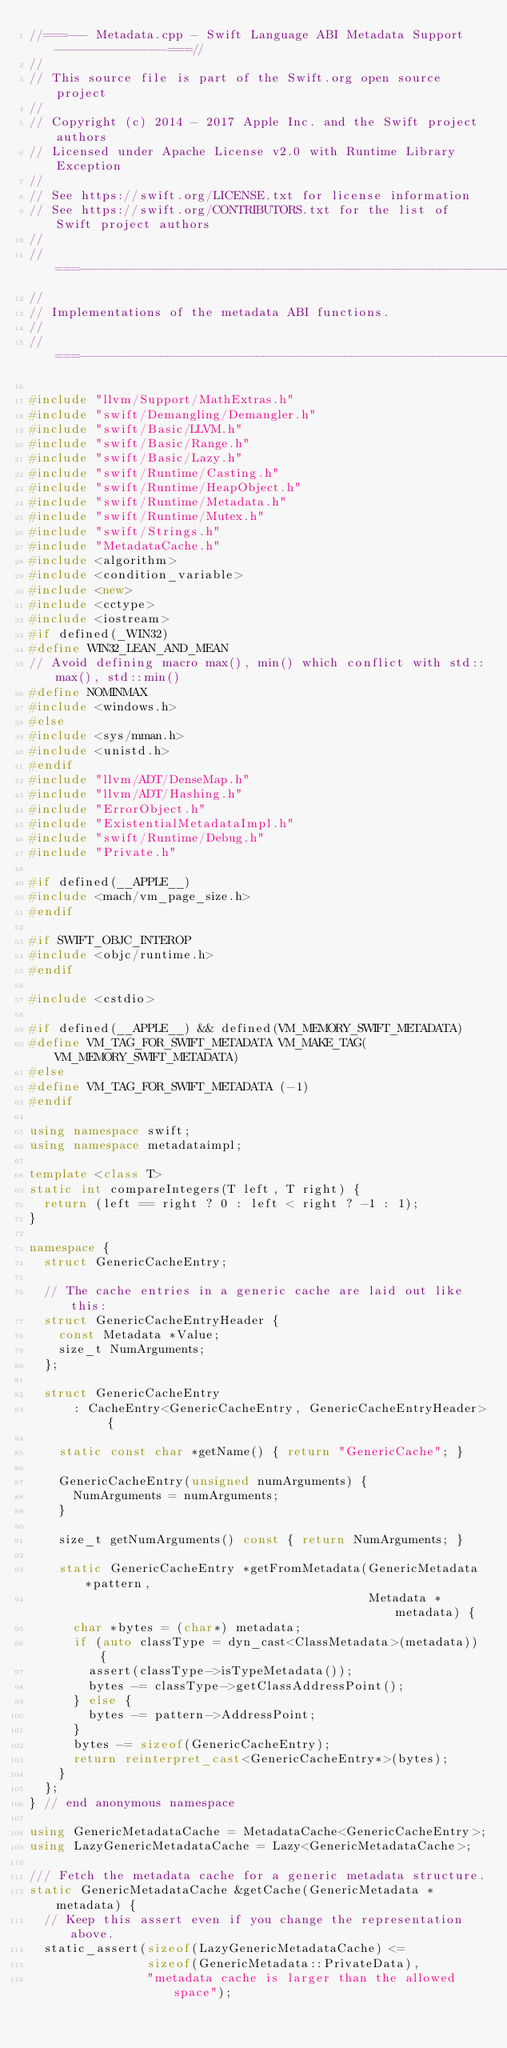<code> <loc_0><loc_0><loc_500><loc_500><_C++_>//===--- Metadata.cpp - Swift Language ABI Metadata Support ---------------===//
//
// This source file is part of the Swift.org open source project
//
// Copyright (c) 2014 - 2017 Apple Inc. and the Swift project authors
// Licensed under Apache License v2.0 with Runtime Library Exception
//
// See https://swift.org/LICENSE.txt for license information
// See https://swift.org/CONTRIBUTORS.txt for the list of Swift project authors
//
//===----------------------------------------------------------------------===//
//
// Implementations of the metadata ABI functions.
//
//===----------------------------------------------------------------------===//

#include "llvm/Support/MathExtras.h"
#include "swift/Demangling/Demangler.h"
#include "swift/Basic/LLVM.h"
#include "swift/Basic/Range.h"
#include "swift/Basic/Lazy.h"
#include "swift/Runtime/Casting.h"
#include "swift/Runtime/HeapObject.h"
#include "swift/Runtime/Metadata.h"
#include "swift/Runtime/Mutex.h"
#include "swift/Strings.h"
#include "MetadataCache.h"
#include <algorithm>
#include <condition_variable>
#include <new>
#include <cctype>
#include <iostream>
#if defined(_WIN32)
#define WIN32_LEAN_AND_MEAN
// Avoid defining macro max(), min() which conflict with std::max(), std::min()
#define NOMINMAX
#include <windows.h>
#else
#include <sys/mman.h>
#include <unistd.h>
#endif
#include "llvm/ADT/DenseMap.h"
#include "llvm/ADT/Hashing.h"
#include "ErrorObject.h"
#include "ExistentialMetadataImpl.h"
#include "swift/Runtime/Debug.h"
#include "Private.h"

#if defined(__APPLE__)
#include <mach/vm_page_size.h>
#endif

#if SWIFT_OBJC_INTEROP
#include <objc/runtime.h>
#endif

#include <cstdio>

#if defined(__APPLE__) && defined(VM_MEMORY_SWIFT_METADATA)
#define VM_TAG_FOR_SWIFT_METADATA VM_MAKE_TAG(VM_MEMORY_SWIFT_METADATA)
#else
#define VM_TAG_FOR_SWIFT_METADATA (-1)
#endif

using namespace swift;
using namespace metadataimpl;

template <class T>
static int compareIntegers(T left, T right) {
  return (left == right ? 0 : left < right ? -1 : 1);
}

namespace {
  struct GenericCacheEntry;

  // The cache entries in a generic cache are laid out like this:
  struct GenericCacheEntryHeader {
    const Metadata *Value;
    size_t NumArguments;
  };

  struct GenericCacheEntry
      : CacheEntry<GenericCacheEntry, GenericCacheEntryHeader> {

    static const char *getName() { return "GenericCache"; }

    GenericCacheEntry(unsigned numArguments) {
      NumArguments = numArguments;
    }

    size_t getNumArguments() const { return NumArguments; }

    static GenericCacheEntry *getFromMetadata(GenericMetadata *pattern,
                                              Metadata *metadata) {
      char *bytes = (char*) metadata;
      if (auto classType = dyn_cast<ClassMetadata>(metadata)) {
        assert(classType->isTypeMetadata());
        bytes -= classType->getClassAddressPoint();
      } else {
        bytes -= pattern->AddressPoint;
      }
      bytes -= sizeof(GenericCacheEntry);
      return reinterpret_cast<GenericCacheEntry*>(bytes);
    }
  };
} // end anonymous namespace

using GenericMetadataCache = MetadataCache<GenericCacheEntry>;
using LazyGenericMetadataCache = Lazy<GenericMetadataCache>;

/// Fetch the metadata cache for a generic metadata structure.
static GenericMetadataCache &getCache(GenericMetadata *metadata) {
  // Keep this assert even if you change the representation above.
  static_assert(sizeof(LazyGenericMetadataCache) <=
                sizeof(GenericMetadata::PrivateData),
                "metadata cache is larger than the allowed space");
</code> 